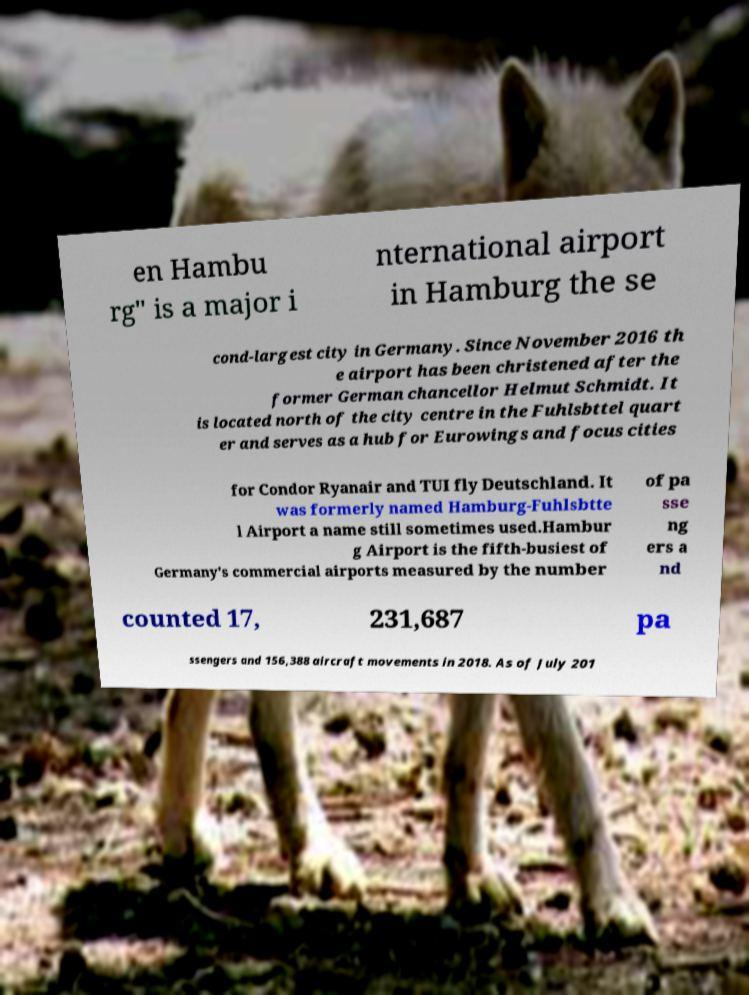Please identify and transcribe the text found in this image. en Hambu rg" is a major i nternational airport in Hamburg the se cond-largest city in Germany. Since November 2016 th e airport has been christened after the former German chancellor Helmut Schmidt. It is located north of the city centre in the Fuhlsbttel quart er and serves as a hub for Eurowings and focus cities for Condor Ryanair and TUI fly Deutschland. It was formerly named Hamburg-Fuhlsbtte l Airport a name still sometimes used.Hambur g Airport is the fifth-busiest of Germany's commercial airports measured by the number of pa sse ng ers a nd counted 17, 231,687 pa ssengers and 156,388 aircraft movements in 2018. As of July 201 